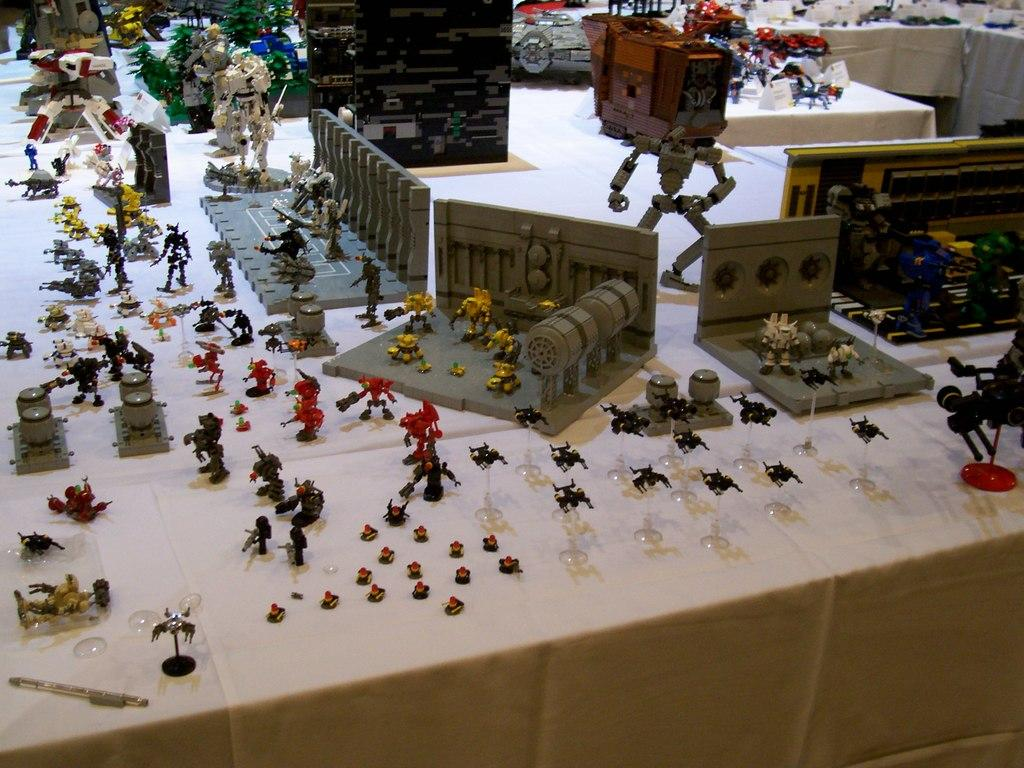What objects are present in the image? There are toys in the image. Can you describe the appearance of the toys? The toys are in different colors. What is the background or surface on which the toys are placed? The toys are on a white color cloth. What type of religion is being practiced by the dinosaurs in the image? There are no dinosaurs present in the image, and therefore no religious practices can be observed. 